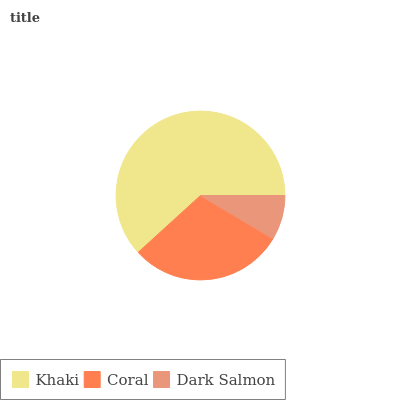Is Dark Salmon the minimum?
Answer yes or no. Yes. Is Khaki the maximum?
Answer yes or no. Yes. Is Coral the minimum?
Answer yes or no. No. Is Coral the maximum?
Answer yes or no. No. Is Khaki greater than Coral?
Answer yes or no. Yes. Is Coral less than Khaki?
Answer yes or no. Yes. Is Coral greater than Khaki?
Answer yes or no. No. Is Khaki less than Coral?
Answer yes or no. No. Is Coral the high median?
Answer yes or no. Yes. Is Coral the low median?
Answer yes or no. Yes. Is Dark Salmon the high median?
Answer yes or no. No. Is Khaki the low median?
Answer yes or no. No. 